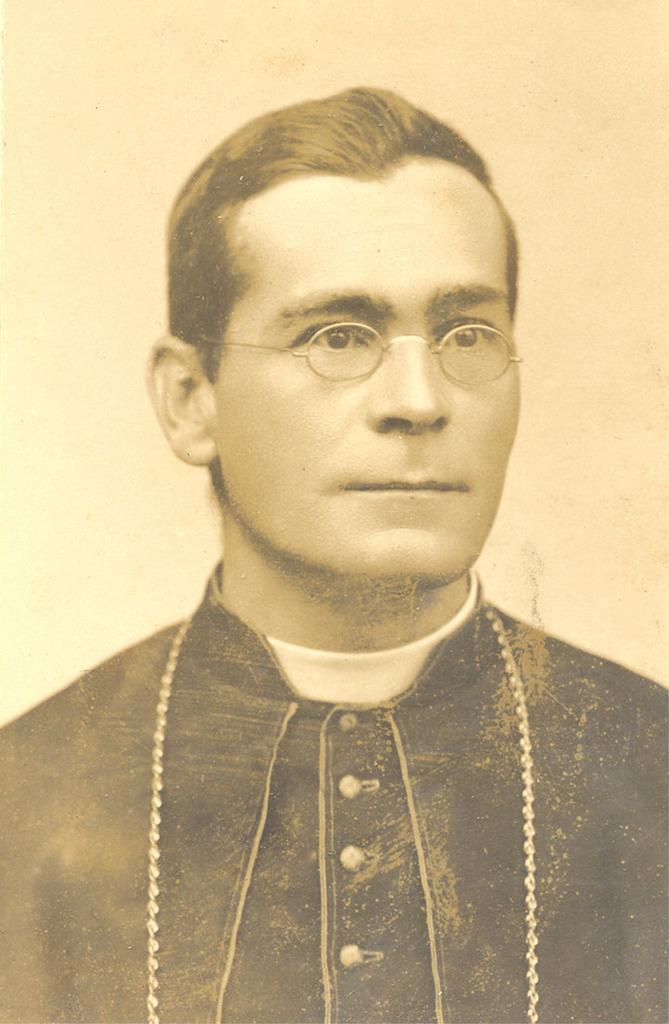Can you describe this image briefly? In this image we can see a person wearing the spectacles and the background looks like the wall. 